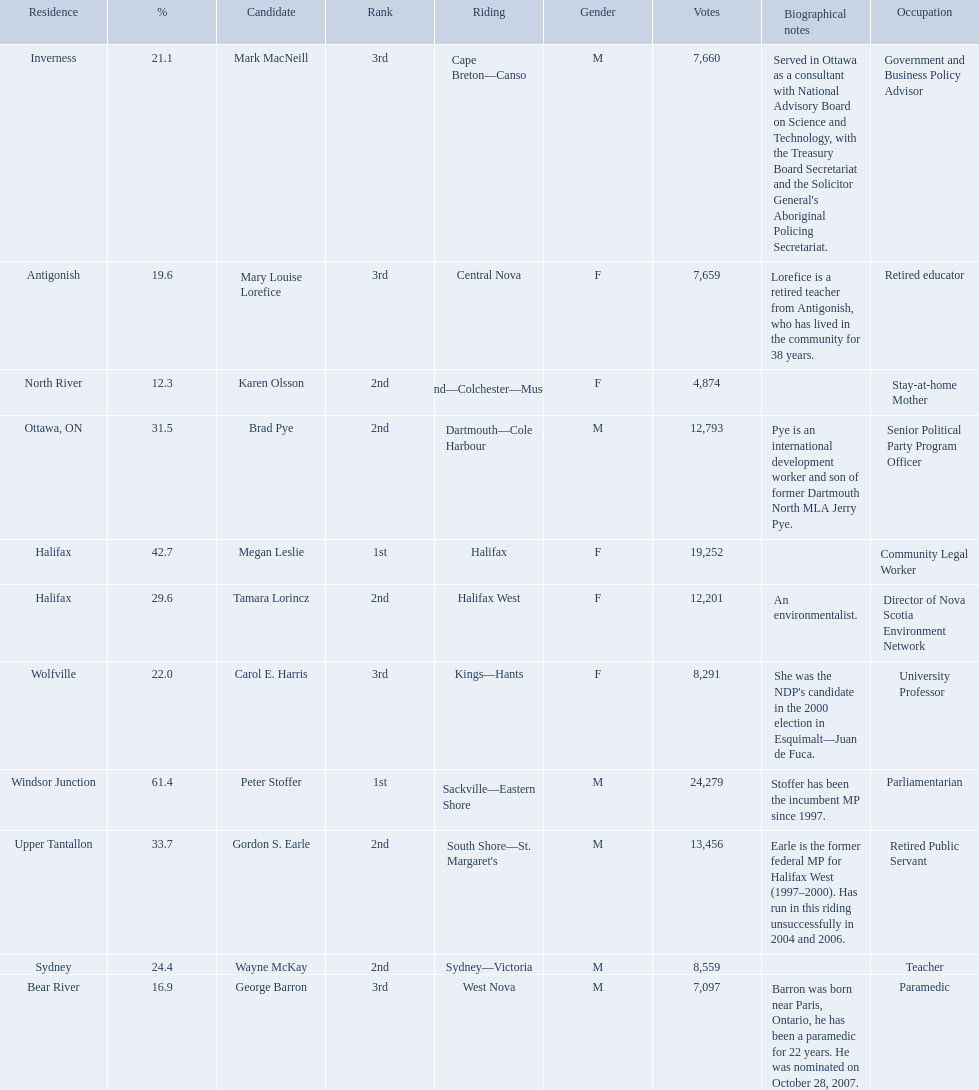Who were all of the new democratic party candidates during the 2008 canadian federal election? Mark MacNeill, Mary Louise Lorefice, Karen Olsson, Brad Pye, Megan Leslie, Tamara Lorincz, Carol E. Harris, Peter Stoffer, Gordon S. Earle, Wayne McKay, George Barron. And between mark macneill and karen olsson, which candidate received more votes? Mark MacNeill. 